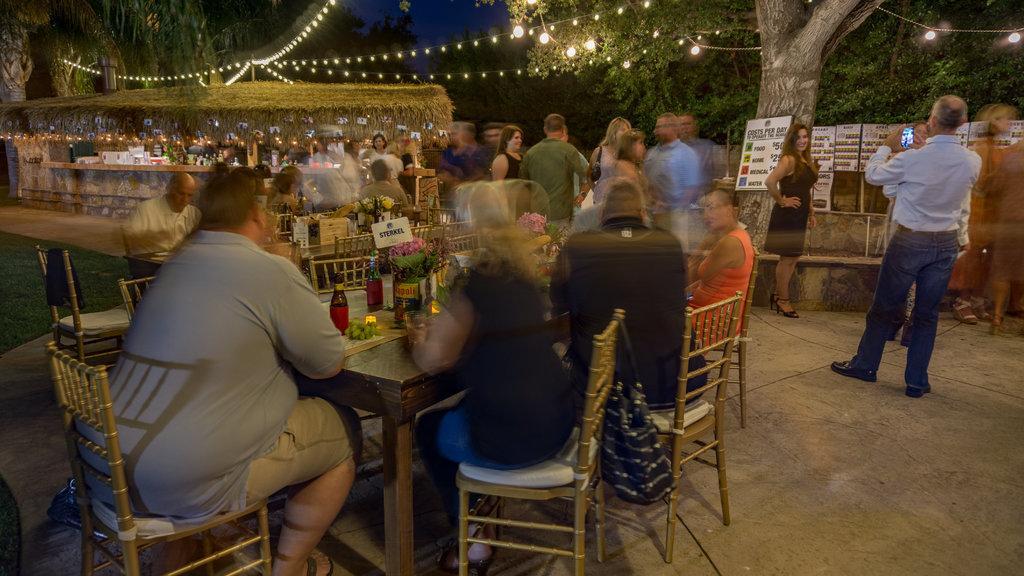How would you summarize this image in a sentence or two? In the image we can see a group of people. We can see group of people who are sitting on chairs in front of a table on table we can see a bottle,grapes,plants,card,flowers On right side there is a woman who is standing and a man who is holding his phone. In background there is a hoarding,trees,lights and sky on top. 